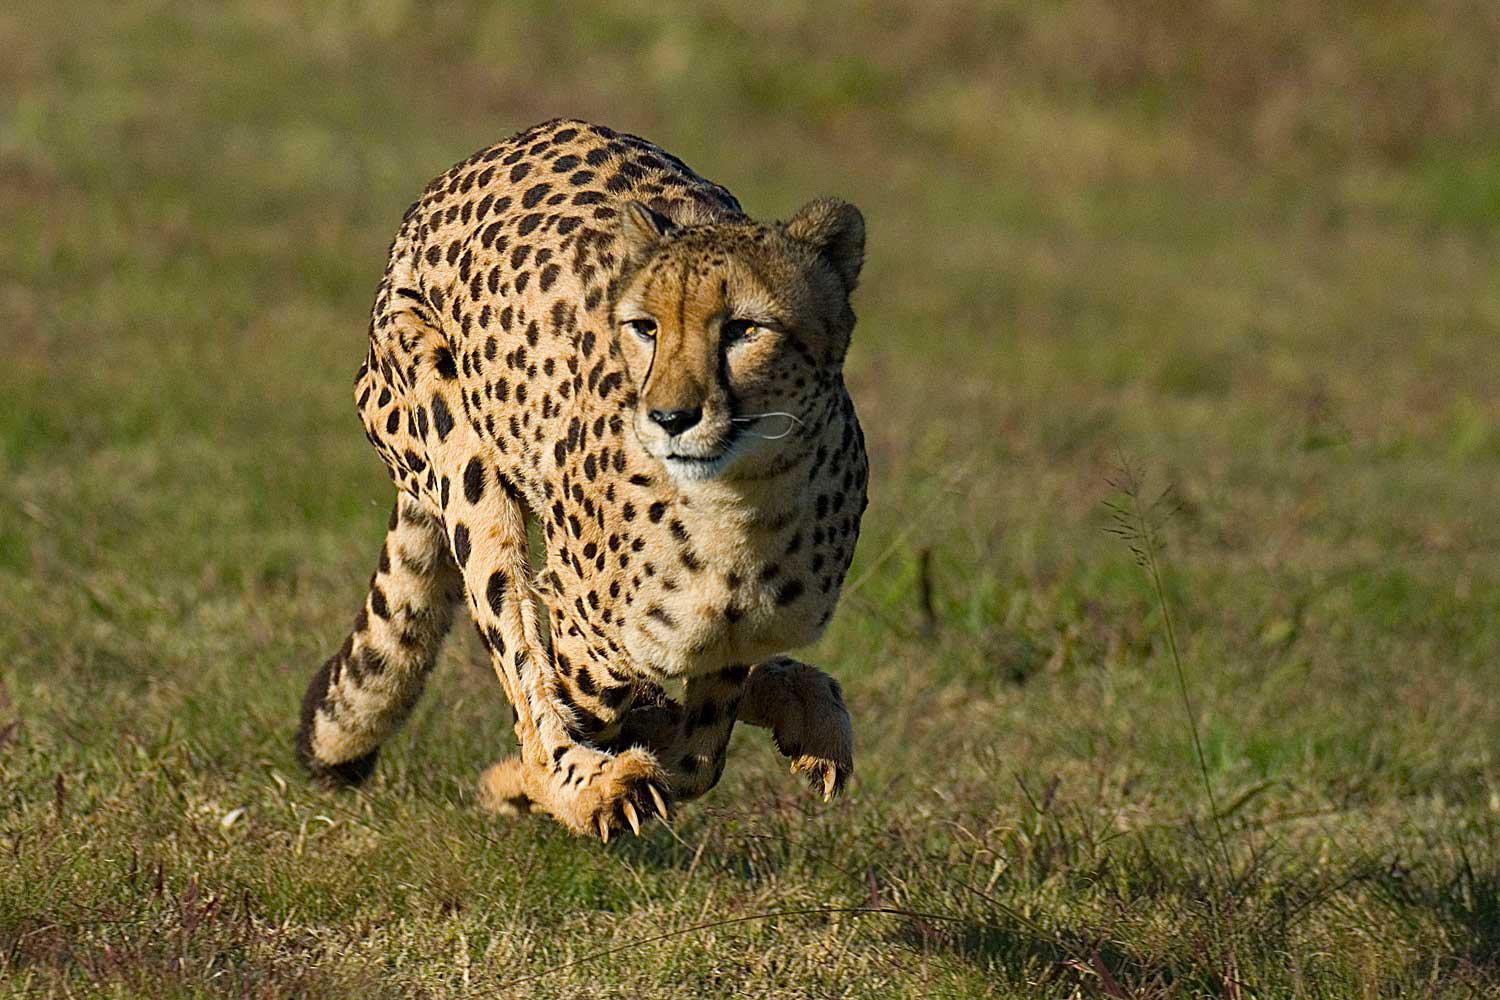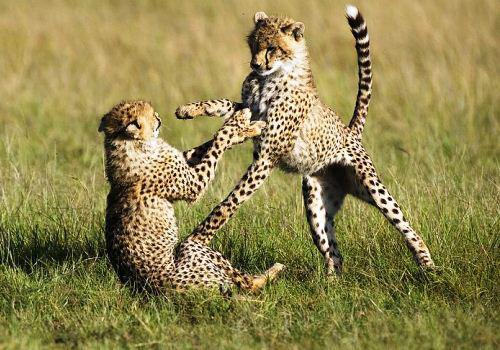The first image is the image on the left, the second image is the image on the right. Assess this claim about the two images: "There are two cheetahs fighting with one of the cheetahs on its backside.". Correct or not? Answer yes or no. Yes. The first image is the image on the left, the second image is the image on the right. For the images displayed, is the sentence "There is a single cheetah in the left image and two cheetahs in the right image." factually correct? Answer yes or no. Yes. 